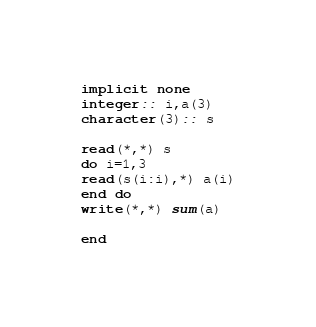Convert code to text. <code><loc_0><loc_0><loc_500><loc_500><_FORTRAN_>implicit none
integer:: i,a(3)
character(3):: s
 
read(*,*) s
do i=1,3
read(s(i:i),*) a(i)
end do
write(*,*) sum(a)
 
end</code> 